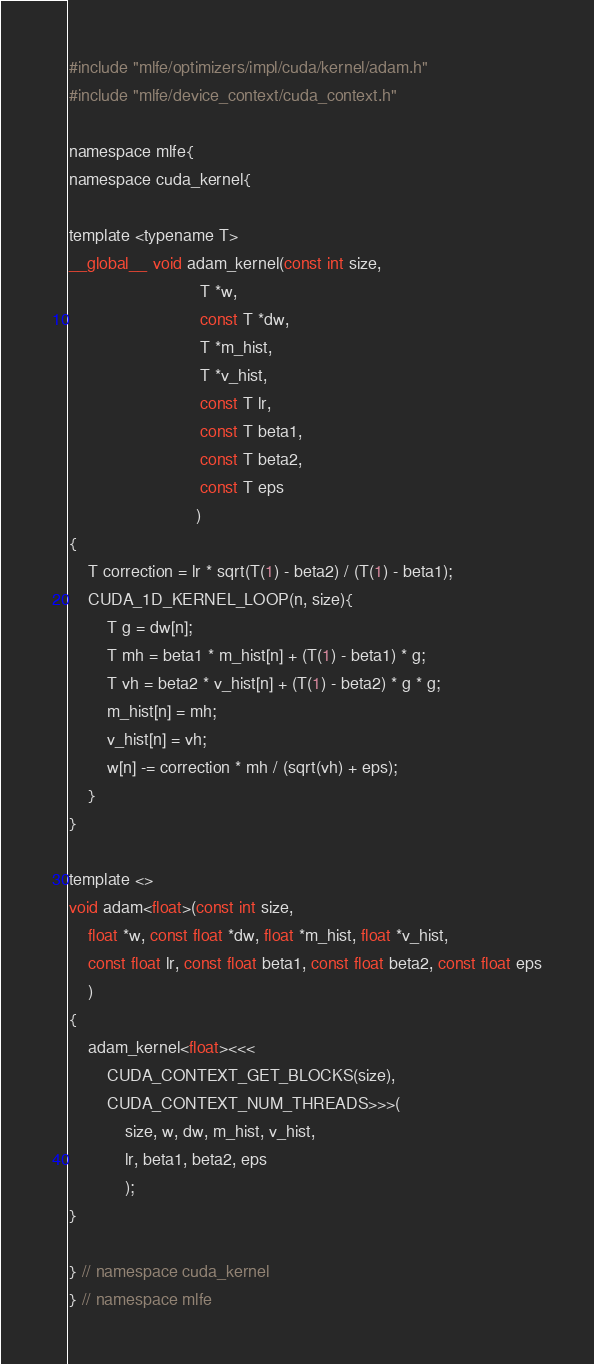<code> <loc_0><loc_0><loc_500><loc_500><_Cuda_>#include "mlfe/optimizers/impl/cuda/kernel/adam.h"
#include "mlfe/device_context/cuda_context.h"

namespace mlfe{
namespace cuda_kernel{

template <typename T>
__global__ void adam_kernel(const int size,
                            T *w,
                            const T *dw,
                            T *m_hist,
                            T *v_hist,
                            const T lr,
                            const T beta1,
                            const T beta2,
                            const T eps
                           )
{
    T correction = lr * sqrt(T(1) - beta2) / (T(1) - beta1);
    CUDA_1D_KERNEL_LOOP(n, size){
        T g = dw[n];
        T mh = beta1 * m_hist[n] + (T(1) - beta1) * g;
        T vh = beta2 * v_hist[n] + (T(1) - beta2) * g * g;
        m_hist[n] = mh;
        v_hist[n] = vh;
        w[n] -= correction * mh / (sqrt(vh) + eps);
    }
}

template <>
void adam<float>(const int size,
    float *w, const float *dw, float *m_hist, float *v_hist,
    const float lr, const float beta1, const float beta2, const float eps
    )
{
    adam_kernel<float><<<
        CUDA_CONTEXT_GET_BLOCKS(size),
        CUDA_CONTEXT_NUM_THREADS>>>(
            size, w, dw, m_hist, v_hist,
            lr, beta1, beta2, eps
            );
}

} // namespace cuda_kernel
} // namespace mlfe</code> 